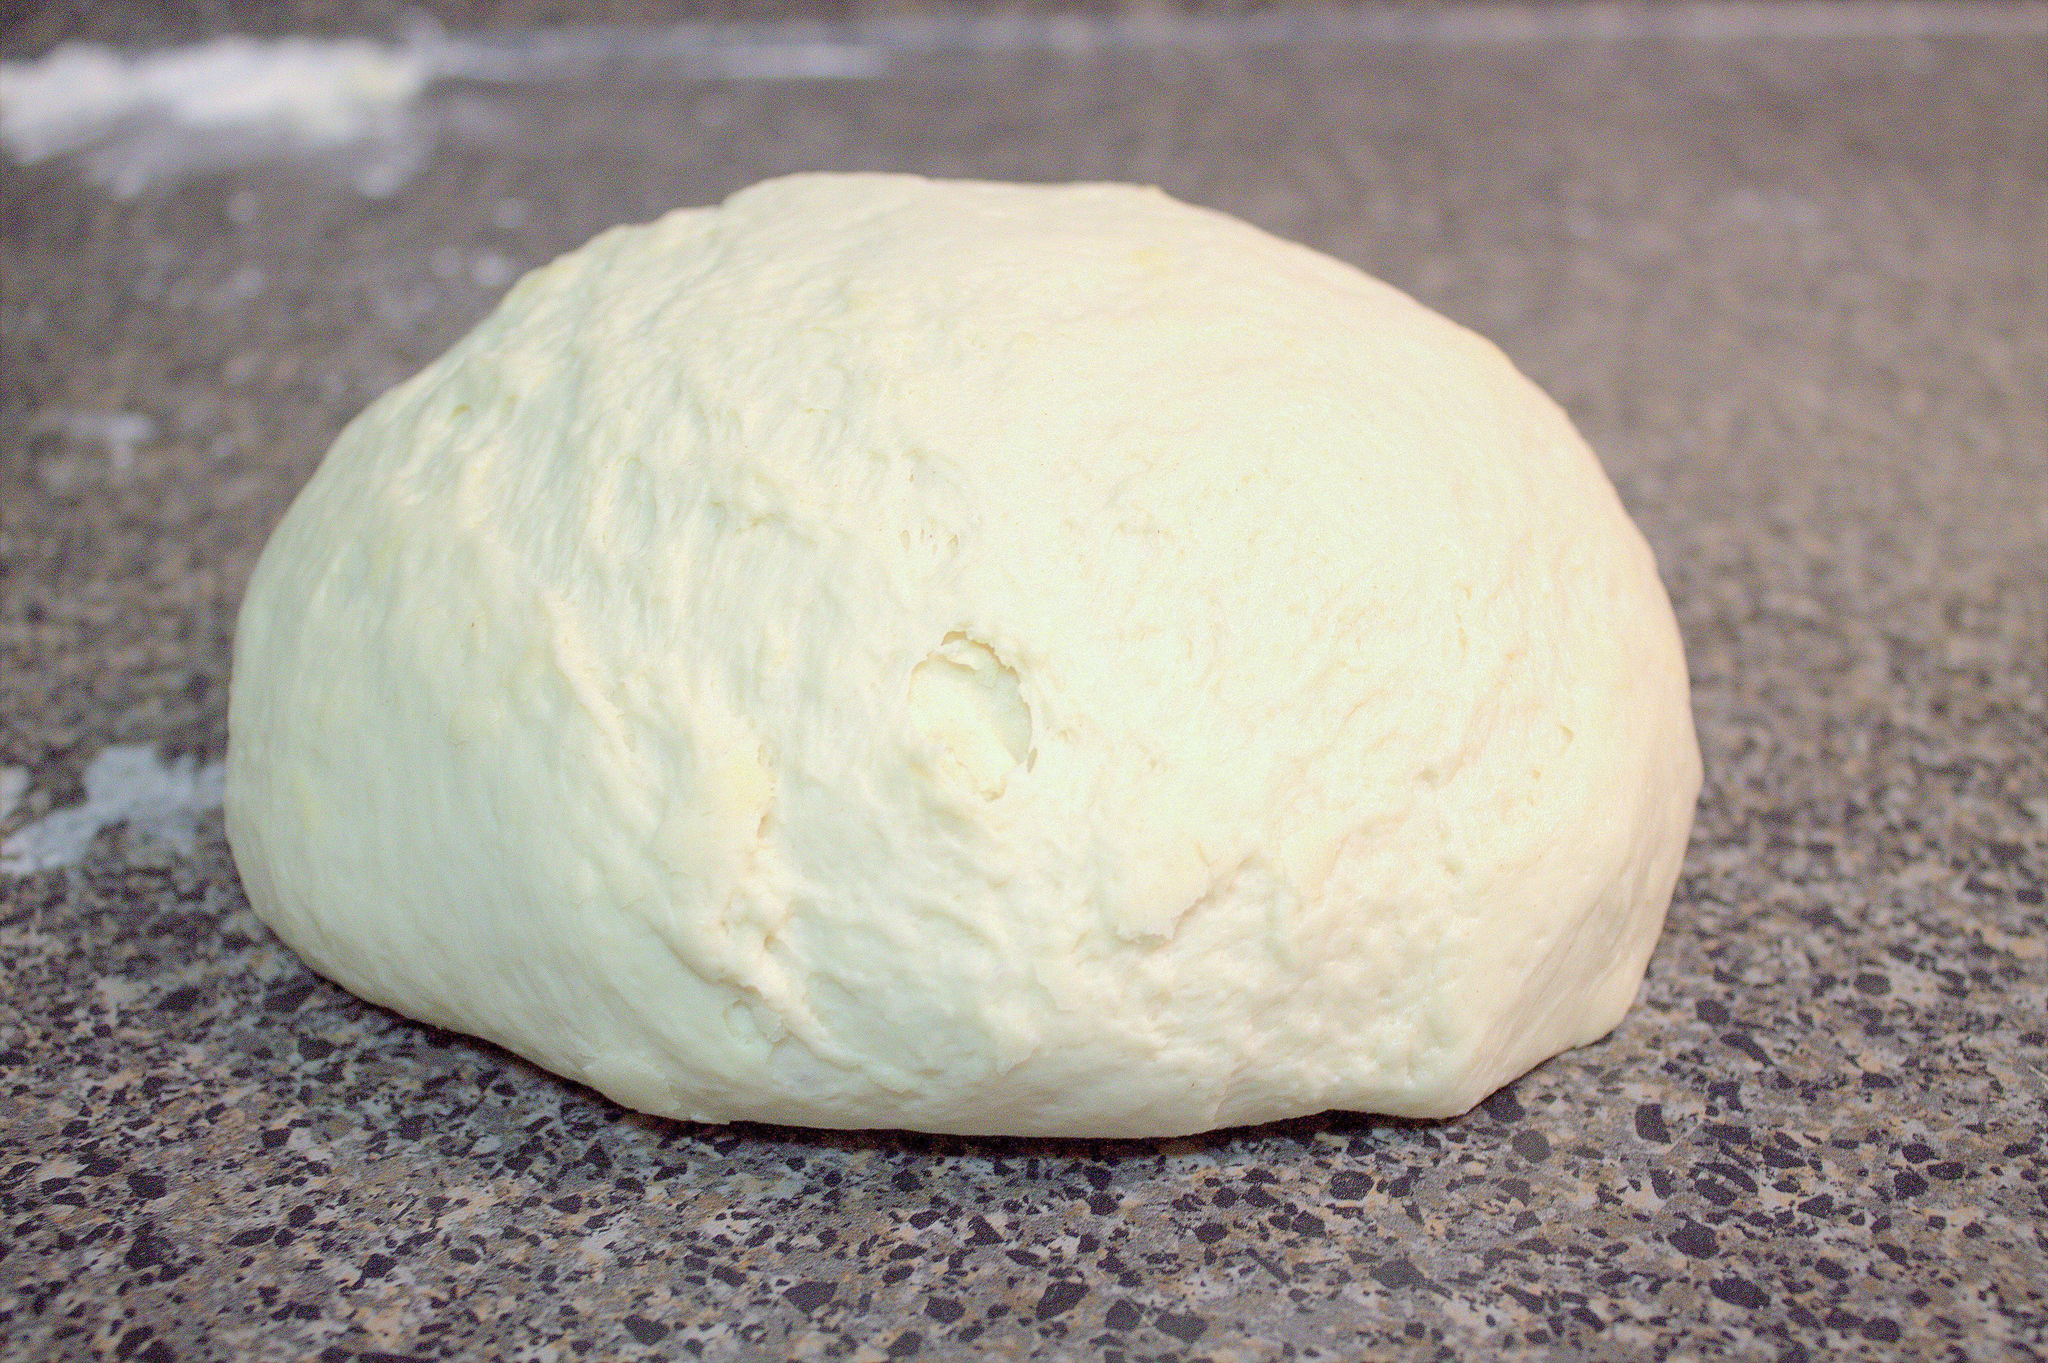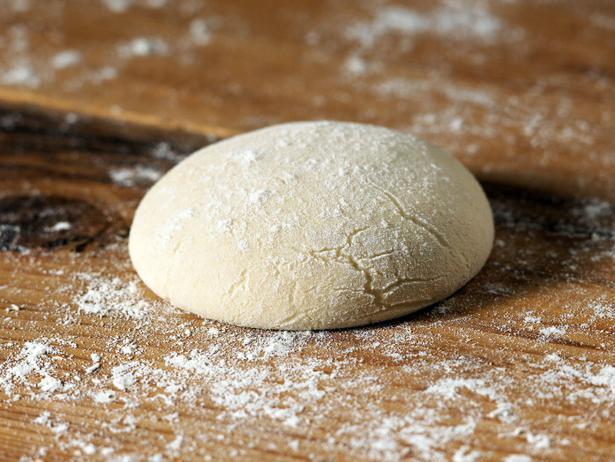The first image is the image on the left, the second image is the image on the right. Evaluate the accuracy of this statement regarding the images: "Each image contains exactly one rounded pale-colored raw dough ball, and one of the images features a dough ball on a wood surface dusted with flour.". Is it true? Answer yes or no. Yes. The first image is the image on the left, the second image is the image on the right. For the images displayed, is the sentence "At least 2 globs of dough have been baked into crusty bread." factually correct? Answer yes or no. No. 